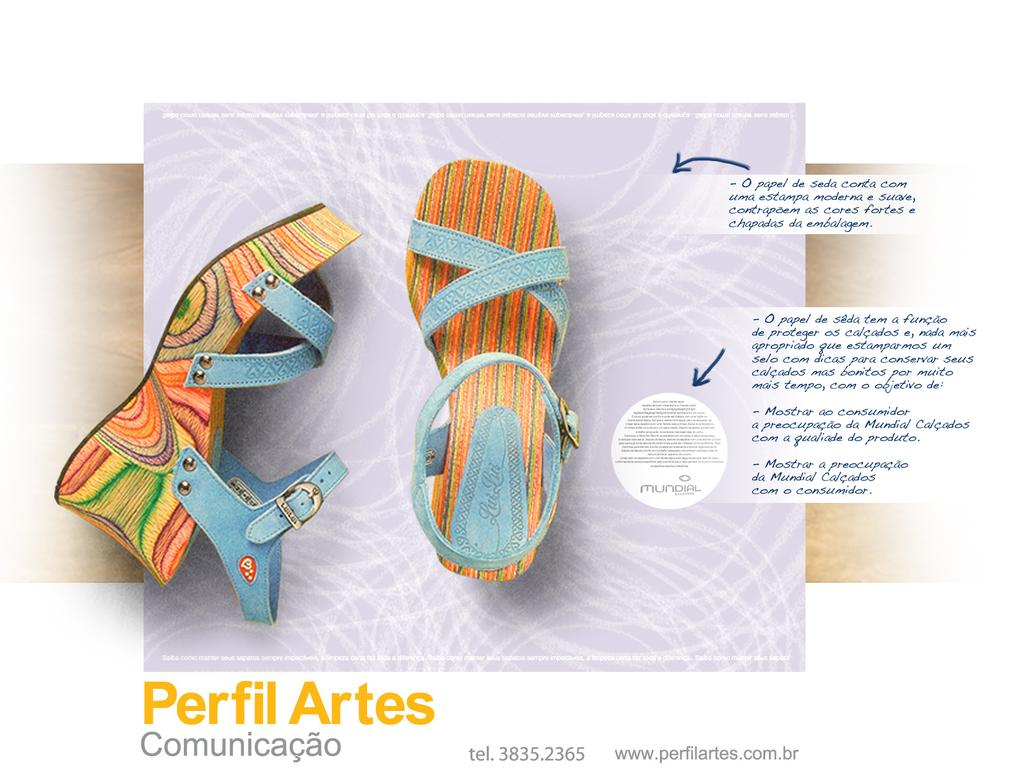What type of objects are featured in the image? The image contains footwear. Where can writing be found in the image? There is writing at the bottom and the right side of the image. What might the purpose of the image be? The image appears to be an advertisement. How many roses are placed on the pancake in the image? There are no roses or pancakes present in the image. What type of sheep can be seen grazing in the image? There are no sheep present in the image. 